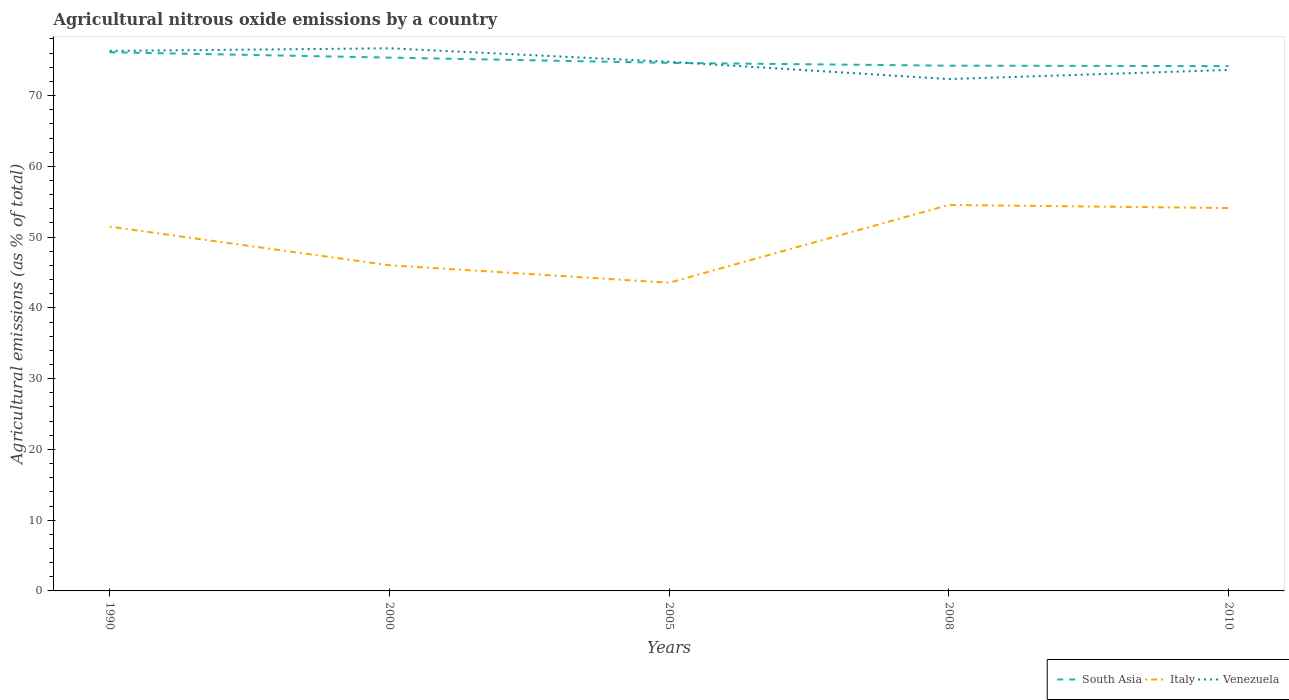How many different coloured lines are there?
Give a very brief answer. 3. Does the line corresponding to South Asia intersect with the line corresponding to Venezuela?
Provide a short and direct response. Yes. Is the number of lines equal to the number of legend labels?
Offer a terse response. Yes. Across all years, what is the maximum amount of agricultural nitrous oxide emitted in Venezuela?
Offer a terse response. 72.33. What is the total amount of agricultural nitrous oxide emitted in South Asia in the graph?
Offer a terse response. 0.46. What is the difference between the highest and the second highest amount of agricultural nitrous oxide emitted in South Asia?
Your answer should be very brief. 1.96. How many lines are there?
Offer a terse response. 3. Are the values on the major ticks of Y-axis written in scientific E-notation?
Ensure brevity in your answer.  No. Does the graph contain grids?
Offer a terse response. No. Where does the legend appear in the graph?
Your answer should be very brief. Bottom right. How many legend labels are there?
Ensure brevity in your answer.  3. How are the legend labels stacked?
Make the answer very short. Horizontal. What is the title of the graph?
Your answer should be compact. Agricultural nitrous oxide emissions by a country. What is the label or title of the X-axis?
Keep it short and to the point. Years. What is the label or title of the Y-axis?
Your answer should be very brief. Agricultural emissions (as % of total). What is the Agricultural emissions (as % of total) in South Asia in 1990?
Provide a short and direct response. 76.12. What is the Agricultural emissions (as % of total) in Italy in 1990?
Keep it short and to the point. 51.48. What is the Agricultural emissions (as % of total) in Venezuela in 1990?
Offer a very short reply. 76.31. What is the Agricultural emissions (as % of total) in South Asia in 2000?
Your answer should be compact. 75.36. What is the Agricultural emissions (as % of total) of Italy in 2000?
Keep it short and to the point. 46.02. What is the Agricultural emissions (as % of total) in Venezuela in 2000?
Keep it short and to the point. 76.68. What is the Agricultural emissions (as % of total) in South Asia in 2005?
Your response must be concise. 74.62. What is the Agricultural emissions (as % of total) of Italy in 2005?
Provide a succinct answer. 43.55. What is the Agricultural emissions (as % of total) in Venezuela in 2005?
Provide a succinct answer. 74.77. What is the Agricultural emissions (as % of total) in South Asia in 2008?
Provide a succinct answer. 74.22. What is the Agricultural emissions (as % of total) in Italy in 2008?
Your answer should be compact. 54.54. What is the Agricultural emissions (as % of total) of Venezuela in 2008?
Provide a succinct answer. 72.33. What is the Agricultural emissions (as % of total) of South Asia in 2010?
Your response must be concise. 74.16. What is the Agricultural emissions (as % of total) in Italy in 2010?
Make the answer very short. 54.1. What is the Agricultural emissions (as % of total) of Venezuela in 2010?
Make the answer very short. 73.62. Across all years, what is the maximum Agricultural emissions (as % of total) in South Asia?
Your answer should be very brief. 76.12. Across all years, what is the maximum Agricultural emissions (as % of total) of Italy?
Ensure brevity in your answer.  54.54. Across all years, what is the maximum Agricultural emissions (as % of total) of Venezuela?
Offer a very short reply. 76.68. Across all years, what is the minimum Agricultural emissions (as % of total) of South Asia?
Ensure brevity in your answer.  74.16. Across all years, what is the minimum Agricultural emissions (as % of total) in Italy?
Ensure brevity in your answer.  43.55. Across all years, what is the minimum Agricultural emissions (as % of total) of Venezuela?
Your response must be concise. 72.33. What is the total Agricultural emissions (as % of total) in South Asia in the graph?
Your answer should be compact. 374.48. What is the total Agricultural emissions (as % of total) in Italy in the graph?
Your answer should be very brief. 249.69. What is the total Agricultural emissions (as % of total) of Venezuela in the graph?
Your answer should be very brief. 373.71. What is the difference between the Agricultural emissions (as % of total) of South Asia in 1990 and that in 2000?
Provide a short and direct response. 0.76. What is the difference between the Agricultural emissions (as % of total) in Italy in 1990 and that in 2000?
Give a very brief answer. 5.46. What is the difference between the Agricultural emissions (as % of total) in Venezuela in 1990 and that in 2000?
Give a very brief answer. -0.37. What is the difference between the Agricultural emissions (as % of total) in South Asia in 1990 and that in 2005?
Offer a very short reply. 1.5. What is the difference between the Agricultural emissions (as % of total) in Italy in 1990 and that in 2005?
Provide a succinct answer. 7.93. What is the difference between the Agricultural emissions (as % of total) of Venezuela in 1990 and that in 2005?
Provide a short and direct response. 1.53. What is the difference between the Agricultural emissions (as % of total) in South Asia in 1990 and that in 2008?
Your response must be concise. 1.9. What is the difference between the Agricultural emissions (as % of total) in Italy in 1990 and that in 2008?
Your answer should be compact. -3.06. What is the difference between the Agricultural emissions (as % of total) in Venezuela in 1990 and that in 2008?
Ensure brevity in your answer.  3.98. What is the difference between the Agricultural emissions (as % of total) of South Asia in 1990 and that in 2010?
Your response must be concise. 1.96. What is the difference between the Agricultural emissions (as % of total) in Italy in 1990 and that in 2010?
Make the answer very short. -2.63. What is the difference between the Agricultural emissions (as % of total) in Venezuela in 1990 and that in 2010?
Provide a succinct answer. 2.69. What is the difference between the Agricultural emissions (as % of total) in South Asia in 2000 and that in 2005?
Make the answer very short. 0.75. What is the difference between the Agricultural emissions (as % of total) of Italy in 2000 and that in 2005?
Your response must be concise. 2.47. What is the difference between the Agricultural emissions (as % of total) in Venezuela in 2000 and that in 2005?
Make the answer very short. 1.9. What is the difference between the Agricultural emissions (as % of total) in South Asia in 2000 and that in 2008?
Your answer should be very brief. 1.14. What is the difference between the Agricultural emissions (as % of total) of Italy in 2000 and that in 2008?
Your answer should be compact. -8.52. What is the difference between the Agricultural emissions (as % of total) in Venezuela in 2000 and that in 2008?
Give a very brief answer. 4.35. What is the difference between the Agricultural emissions (as % of total) of South Asia in 2000 and that in 2010?
Keep it short and to the point. 1.2. What is the difference between the Agricultural emissions (as % of total) of Italy in 2000 and that in 2010?
Keep it short and to the point. -8.09. What is the difference between the Agricultural emissions (as % of total) in Venezuela in 2000 and that in 2010?
Your answer should be compact. 3.06. What is the difference between the Agricultural emissions (as % of total) of South Asia in 2005 and that in 2008?
Offer a terse response. 0.39. What is the difference between the Agricultural emissions (as % of total) in Italy in 2005 and that in 2008?
Give a very brief answer. -10.99. What is the difference between the Agricultural emissions (as % of total) in Venezuela in 2005 and that in 2008?
Provide a short and direct response. 2.44. What is the difference between the Agricultural emissions (as % of total) in South Asia in 2005 and that in 2010?
Offer a terse response. 0.46. What is the difference between the Agricultural emissions (as % of total) of Italy in 2005 and that in 2010?
Your answer should be compact. -10.56. What is the difference between the Agricultural emissions (as % of total) of Venezuela in 2005 and that in 2010?
Your answer should be very brief. 1.16. What is the difference between the Agricultural emissions (as % of total) in South Asia in 2008 and that in 2010?
Make the answer very short. 0.06. What is the difference between the Agricultural emissions (as % of total) of Italy in 2008 and that in 2010?
Give a very brief answer. 0.44. What is the difference between the Agricultural emissions (as % of total) of Venezuela in 2008 and that in 2010?
Provide a short and direct response. -1.29. What is the difference between the Agricultural emissions (as % of total) of South Asia in 1990 and the Agricultural emissions (as % of total) of Italy in 2000?
Offer a very short reply. 30.1. What is the difference between the Agricultural emissions (as % of total) in South Asia in 1990 and the Agricultural emissions (as % of total) in Venezuela in 2000?
Offer a terse response. -0.56. What is the difference between the Agricultural emissions (as % of total) of Italy in 1990 and the Agricultural emissions (as % of total) of Venezuela in 2000?
Offer a very short reply. -25.2. What is the difference between the Agricultural emissions (as % of total) of South Asia in 1990 and the Agricultural emissions (as % of total) of Italy in 2005?
Your answer should be compact. 32.57. What is the difference between the Agricultural emissions (as % of total) in South Asia in 1990 and the Agricultural emissions (as % of total) in Venezuela in 2005?
Ensure brevity in your answer.  1.35. What is the difference between the Agricultural emissions (as % of total) of Italy in 1990 and the Agricultural emissions (as % of total) of Venezuela in 2005?
Provide a short and direct response. -23.3. What is the difference between the Agricultural emissions (as % of total) in South Asia in 1990 and the Agricultural emissions (as % of total) in Italy in 2008?
Provide a short and direct response. 21.58. What is the difference between the Agricultural emissions (as % of total) in South Asia in 1990 and the Agricultural emissions (as % of total) in Venezuela in 2008?
Ensure brevity in your answer.  3.79. What is the difference between the Agricultural emissions (as % of total) in Italy in 1990 and the Agricultural emissions (as % of total) in Venezuela in 2008?
Make the answer very short. -20.85. What is the difference between the Agricultural emissions (as % of total) in South Asia in 1990 and the Agricultural emissions (as % of total) in Italy in 2010?
Offer a very short reply. 22.01. What is the difference between the Agricultural emissions (as % of total) in South Asia in 1990 and the Agricultural emissions (as % of total) in Venezuela in 2010?
Offer a terse response. 2.5. What is the difference between the Agricultural emissions (as % of total) of Italy in 1990 and the Agricultural emissions (as % of total) of Venezuela in 2010?
Your answer should be compact. -22.14. What is the difference between the Agricultural emissions (as % of total) of South Asia in 2000 and the Agricultural emissions (as % of total) of Italy in 2005?
Your answer should be very brief. 31.81. What is the difference between the Agricultural emissions (as % of total) in South Asia in 2000 and the Agricultural emissions (as % of total) in Venezuela in 2005?
Your response must be concise. 0.59. What is the difference between the Agricultural emissions (as % of total) of Italy in 2000 and the Agricultural emissions (as % of total) of Venezuela in 2005?
Your answer should be very brief. -28.76. What is the difference between the Agricultural emissions (as % of total) of South Asia in 2000 and the Agricultural emissions (as % of total) of Italy in 2008?
Your answer should be compact. 20.82. What is the difference between the Agricultural emissions (as % of total) in South Asia in 2000 and the Agricultural emissions (as % of total) in Venezuela in 2008?
Provide a succinct answer. 3.03. What is the difference between the Agricultural emissions (as % of total) of Italy in 2000 and the Agricultural emissions (as % of total) of Venezuela in 2008?
Your response must be concise. -26.31. What is the difference between the Agricultural emissions (as % of total) of South Asia in 2000 and the Agricultural emissions (as % of total) of Italy in 2010?
Offer a terse response. 21.26. What is the difference between the Agricultural emissions (as % of total) in South Asia in 2000 and the Agricultural emissions (as % of total) in Venezuela in 2010?
Provide a succinct answer. 1.74. What is the difference between the Agricultural emissions (as % of total) of Italy in 2000 and the Agricultural emissions (as % of total) of Venezuela in 2010?
Offer a terse response. -27.6. What is the difference between the Agricultural emissions (as % of total) in South Asia in 2005 and the Agricultural emissions (as % of total) in Italy in 2008?
Ensure brevity in your answer.  20.07. What is the difference between the Agricultural emissions (as % of total) in South Asia in 2005 and the Agricultural emissions (as % of total) in Venezuela in 2008?
Provide a succinct answer. 2.29. What is the difference between the Agricultural emissions (as % of total) of Italy in 2005 and the Agricultural emissions (as % of total) of Venezuela in 2008?
Make the answer very short. -28.78. What is the difference between the Agricultural emissions (as % of total) in South Asia in 2005 and the Agricultural emissions (as % of total) in Italy in 2010?
Provide a succinct answer. 20.51. What is the difference between the Agricultural emissions (as % of total) of Italy in 2005 and the Agricultural emissions (as % of total) of Venezuela in 2010?
Keep it short and to the point. -30.07. What is the difference between the Agricultural emissions (as % of total) in South Asia in 2008 and the Agricultural emissions (as % of total) in Italy in 2010?
Provide a short and direct response. 20.12. What is the difference between the Agricultural emissions (as % of total) in South Asia in 2008 and the Agricultural emissions (as % of total) in Venezuela in 2010?
Your answer should be compact. 0.6. What is the difference between the Agricultural emissions (as % of total) in Italy in 2008 and the Agricultural emissions (as % of total) in Venezuela in 2010?
Give a very brief answer. -19.08. What is the average Agricultural emissions (as % of total) in South Asia per year?
Ensure brevity in your answer.  74.9. What is the average Agricultural emissions (as % of total) in Italy per year?
Offer a terse response. 49.94. What is the average Agricultural emissions (as % of total) of Venezuela per year?
Your answer should be very brief. 74.74. In the year 1990, what is the difference between the Agricultural emissions (as % of total) in South Asia and Agricultural emissions (as % of total) in Italy?
Your answer should be very brief. 24.64. In the year 1990, what is the difference between the Agricultural emissions (as % of total) of South Asia and Agricultural emissions (as % of total) of Venezuela?
Ensure brevity in your answer.  -0.19. In the year 1990, what is the difference between the Agricultural emissions (as % of total) of Italy and Agricultural emissions (as % of total) of Venezuela?
Give a very brief answer. -24.83. In the year 2000, what is the difference between the Agricultural emissions (as % of total) in South Asia and Agricultural emissions (as % of total) in Italy?
Give a very brief answer. 29.34. In the year 2000, what is the difference between the Agricultural emissions (as % of total) in South Asia and Agricultural emissions (as % of total) in Venezuela?
Offer a terse response. -1.31. In the year 2000, what is the difference between the Agricultural emissions (as % of total) in Italy and Agricultural emissions (as % of total) in Venezuela?
Your response must be concise. -30.66. In the year 2005, what is the difference between the Agricultural emissions (as % of total) of South Asia and Agricultural emissions (as % of total) of Italy?
Offer a very short reply. 31.07. In the year 2005, what is the difference between the Agricultural emissions (as % of total) of South Asia and Agricultural emissions (as % of total) of Venezuela?
Your response must be concise. -0.16. In the year 2005, what is the difference between the Agricultural emissions (as % of total) in Italy and Agricultural emissions (as % of total) in Venezuela?
Your answer should be very brief. -31.22. In the year 2008, what is the difference between the Agricultural emissions (as % of total) in South Asia and Agricultural emissions (as % of total) in Italy?
Give a very brief answer. 19.68. In the year 2008, what is the difference between the Agricultural emissions (as % of total) of South Asia and Agricultural emissions (as % of total) of Venezuela?
Make the answer very short. 1.89. In the year 2008, what is the difference between the Agricultural emissions (as % of total) of Italy and Agricultural emissions (as % of total) of Venezuela?
Offer a terse response. -17.79. In the year 2010, what is the difference between the Agricultural emissions (as % of total) of South Asia and Agricultural emissions (as % of total) of Italy?
Offer a very short reply. 20.06. In the year 2010, what is the difference between the Agricultural emissions (as % of total) of South Asia and Agricultural emissions (as % of total) of Venezuela?
Keep it short and to the point. 0.54. In the year 2010, what is the difference between the Agricultural emissions (as % of total) in Italy and Agricultural emissions (as % of total) in Venezuela?
Your answer should be compact. -19.51. What is the ratio of the Agricultural emissions (as % of total) of Italy in 1990 to that in 2000?
Make the answer very short. 1.12. What is the ratio of the Agricultural emissions (as % of total) of Venezuela in 1990 to that in 2000?
Provide a short and direct response. 1. What is the ratio of the Agricultural emissions (as % of total) of South Asia in 1990 to that in 2005?
Give a very brief answer. 1.02. What is the ratio of the Agricultural emissions (as % of total) in Italy in 1990 to that in 2005?
Offer a very short reply. 1.18. What is the ratio of the Agricultural emissions (as % of total) in Venezuela in 1990 to that in 2005?
Make the answer very short. 1.02. What is the ratio of the Agricultural emissions (as % of total) of South Asia in 1990 to that in 2008?
Your answer should be very brief. 1.03. What is the ratio of the Agricultural emissions (as % of total) of Italy in 1990 to that in 2008?
Your answer should be very brief. 0.94. What is the ratio of the Agricultural emissions (as % of total) in Venezuela in 1990 to that in 2008?
Provide a short and direct response. 1.05. What is the ratio of the Agricultural emissions (as % of total) in South Asia in 1990 to that in 2010?
Offer a very short reply. 1.03. What is the ratio of the Agricultural emissions (as % of total) of Italy in 1990 to that in 2010?
Keep it short and to the point. 0.95. What is the ratio of the Agricultural emissions (as % of total) in Venezuela in 1990 to that in 2010?
Provide a short and direct response. 1.04. What is the ratio of the Agricultural emissions (as % of total) of Italy in 2000 to that in 2005?
Ensure brevity in your answer.  1.06. What is the ratio of the Agricultural emissions (as % of total) of Venezuela in 2000 to that in 2005?
Give a very brief answer. 1.03. What is the ratio of the Agricultural emissions (as % of total) of South Asia in 2000 to that in 2008?
Give a very brief answer. 1.02. What is the ratio of the Agricultural emissions (as % of total) in Italy in 2000 to that in 2008?
Your response must be concise. 0.84. What is the ratio of the Agricultural emissions (as % of total) of Venezuela in 2000 to that in 2008?
Ensure brevity in your answer.  1.06. What is the ratio of the Agricultural emissions (as % of total) in South Asia in 2000 to that in 2010?
Offer a very short reply. 1.02. What is the ratio of the Agricultural emissions (as % of total) of Italy in 2000 to that in 2010?
Provide a succinct answer. 0.85. What is the ratio of the Agricultural emissions (as % of total) in Venezuela in 2000 to that in 2010?
Ensure brevity in your answer.  1.04. What is the ratio of the Agricultural emissions (as % of total) of Italy in 2005 to that in 2008?
Make the answer very short. 0.8. What is the ratio of the Agricultural emissions (as % of total) of Venezuela in 2005 to that in 2008?
Give a very brief answer. 1.03. What is the ratio of the Agricultural emissions (as % of total) in South Asia in 2005 to that in 2010?
Provide a succinct answer. 1.01. What is the ratio of the Agricultural emissions (as % of total) in Italy in 2005 to that in 2010?
Provide a short and direct response. 0.8. What is the ratio of the Agricultural emissions (as % of total) of Venezuela in 2005 to that in 2010?
Offer a very short reply. 1.02. What is the ratio of the Agricultural emissions (as % of total) of Italy in 2008 to that in 2010?
Make the answer very short. 1.01. What is the ratio of the Agricultural emissions (as % of total) in Venezuela in 2008 to that in 2010?
Provide a short and direct response. 0.98. What is the difference between the highest and the second highest Agricultural emissions (as % of total) of South Asia?
Your answer should be compact. 0.76. What is the difference between the highest and the second highest Agricultural emissions (as % of total) of Italy?
Your answer should be very brief. 0.44. What is the difference between the highest and the second highest Agricultural emissions (as % of total) in Venezuela?
Offer a terse response. 0.37. What is the difference between the highest and the lowest Agricultural emissions (as % of total) of South Asia?
Provide a short and direct response. 1.96. What is the difference between the highest and the lowest Agricultural emissions (as % of total) of Italy?
Keep it short and to the point. 10.99. What is the difference between the highest and the lowest Agricultural emissions (as % of total) of Venezuela?
Provide a short and direct response. 4.35. 